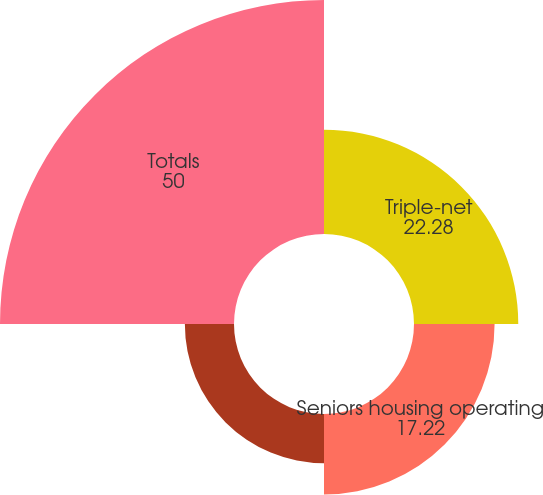<chart> <loc_0><loc_0><loc_500><loc_500><pie_chart><fcel>Triple-net<fcel>Seniors housing operating<fcel>Outpatient medical<fcel>Totals<nl><fcel>22.28%<fcel>17.22%<fcel>10.5%<fcel>50.0%<nl></chart> 